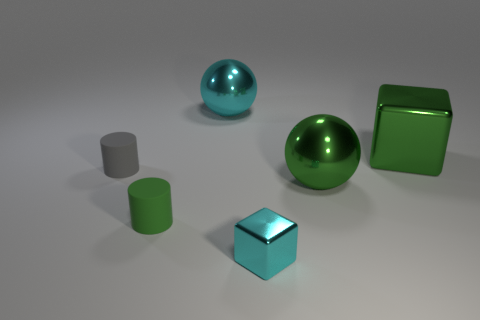There is another object that is the same shape as the gray thing; what is its material?
Keep it short and to the point. Rubber. There is a metal ball that is to the left of the cyan shiny thing to the right of the big cyan object; how many big green metallic things are to the left of it?
Make the answer very short. 0. Are there any other things that have the same color as the big cube?
Ensure brevity in your answer.  Yes. What number of things are behind the gray thing and left of the green metal block?
Ensure brevity in your answer.  1. Does the shiny ball that is right of the tiny metallic block have the same size as the gray cylinder left of the green cylinder?
Give a very brief answer. No. What number of things are cyan objects that are behind the large green cube or big blue metal things?
Provide a short and direct response. 1. There is a small object that is left of the green cylinder; what material is it?
Your response must be concise. Rubber. What is the material of the green sphere?
Make the answer very short. Metal. There is a cyan object behind the tiny matte cylinder behind the tiny matte object that is to the right of the gray cylinder; what is its material?
Offer a terse response. Metal. Is there anything else that is the same material as the small cyan thing?
Ensure brevity in your answer.  Yes. 